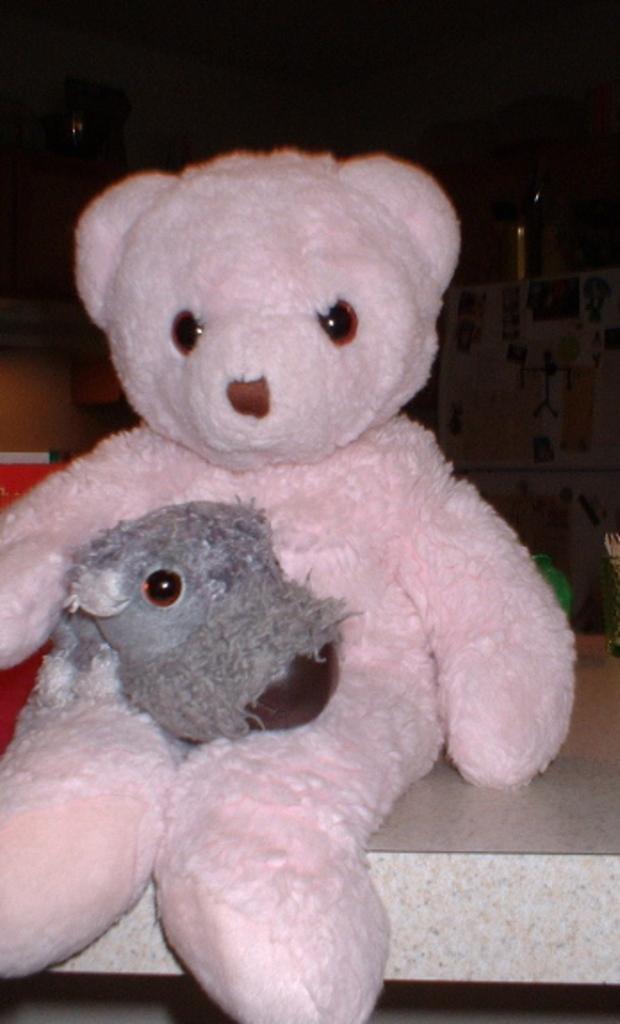In one or two sentences, can you explain what this image depicts? In this image there is one white color doll as we can see in middle of this image. Is kept on a white colored object. 